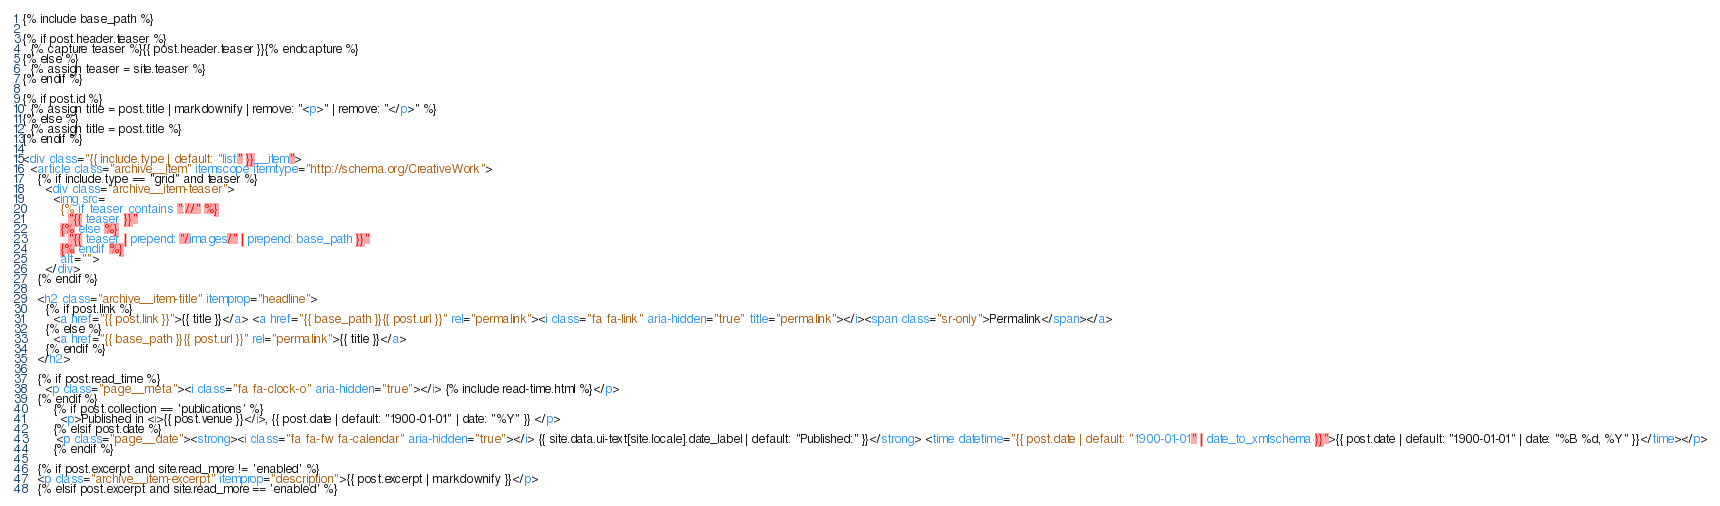Convert code to text. <code><loc_0><loc_0><loc_500><loc_500><_HTML_>{% include base_path %}

{% if post.header.teaser %}
  {% capture teaser %}{{ post.header.teaser }}{% endcapture %}
{% else %}
  {% assign teaser = site.teaser %}
{% endif %}

{% if post.id %}
  {% assign title = post.title | markdownify | remove: "<p>" | remove: "</p>" %}
{% else %}
  {% assign title = post.title %}
{% endif %}

<div class="{{ include.type | default: "list" }}__item">
  <article class="archive__item" itemscope itemtype="http://schema.org/CreativeWork">
    {% if include.type == "grid" and teaser %}
      <div class="archive__item-teaser">
        <img src=
          {% if teaser contains "://" %}
            "{{ teaser }}"
          {% else %}
            "{{ teaser | prepend: "/images/" | prepend: base_path }}"
          {% endif %}
          alt="">
      </div>
    {% endif %}

    <h2 class="archive__item-title" itemprop="headline">
      {% if post.link %}
        <a href="{{ post.link }}">{{ title }}</a> <a href="{{ base_path }}{{ post.url }}" rel="permalink"><i class="fa fa-link" aria-hidden="true" title="permalink"></i><span class="sr-only">Permalink</span></a>
      {% else %}
        <a href="{{ base_path }}{{ post.url }}" rel="permalink">{{ title }}</a>
      {% endif %}
    </h2>
    
    {% if post.read_time %}
      <p class="page__meta"><i class="fa fa-clock-o" aria-hidden="true"></i> {% include read-time.html %}</p>
    {% endif %}
        {% if post.collection == 'publications' %}
          <p>Published in <i>{{ post.venue }}</i>, {{ post.date | default: "1900-01-01" | date: "%Y" }} </p>
        {% elsif post.date %}
         <p class="page__date"><strong><i class="fa fa-fw fa-calendar" aria-hidden="true"></i> {{ site.data.ui-text[site.locale].date_label | default: "Published:" }}</strong> <time datetime="{{ post.date | default: "1900-01-01" | date_to_xmlschema }}">{{ post.date | default: "1900-01-01" | date: "%B %d, %Y" }}</time></p>
        {% endif %}

    {% if post.excerpt and site.read_more != 'enabled' %}
    <p class="archive__item-excerpt" itemprop="description">{{ post.excerpt | markdownify }}</p>
    {% elsif post.excerpt and site.read_more == 'enabled' %}</code> 